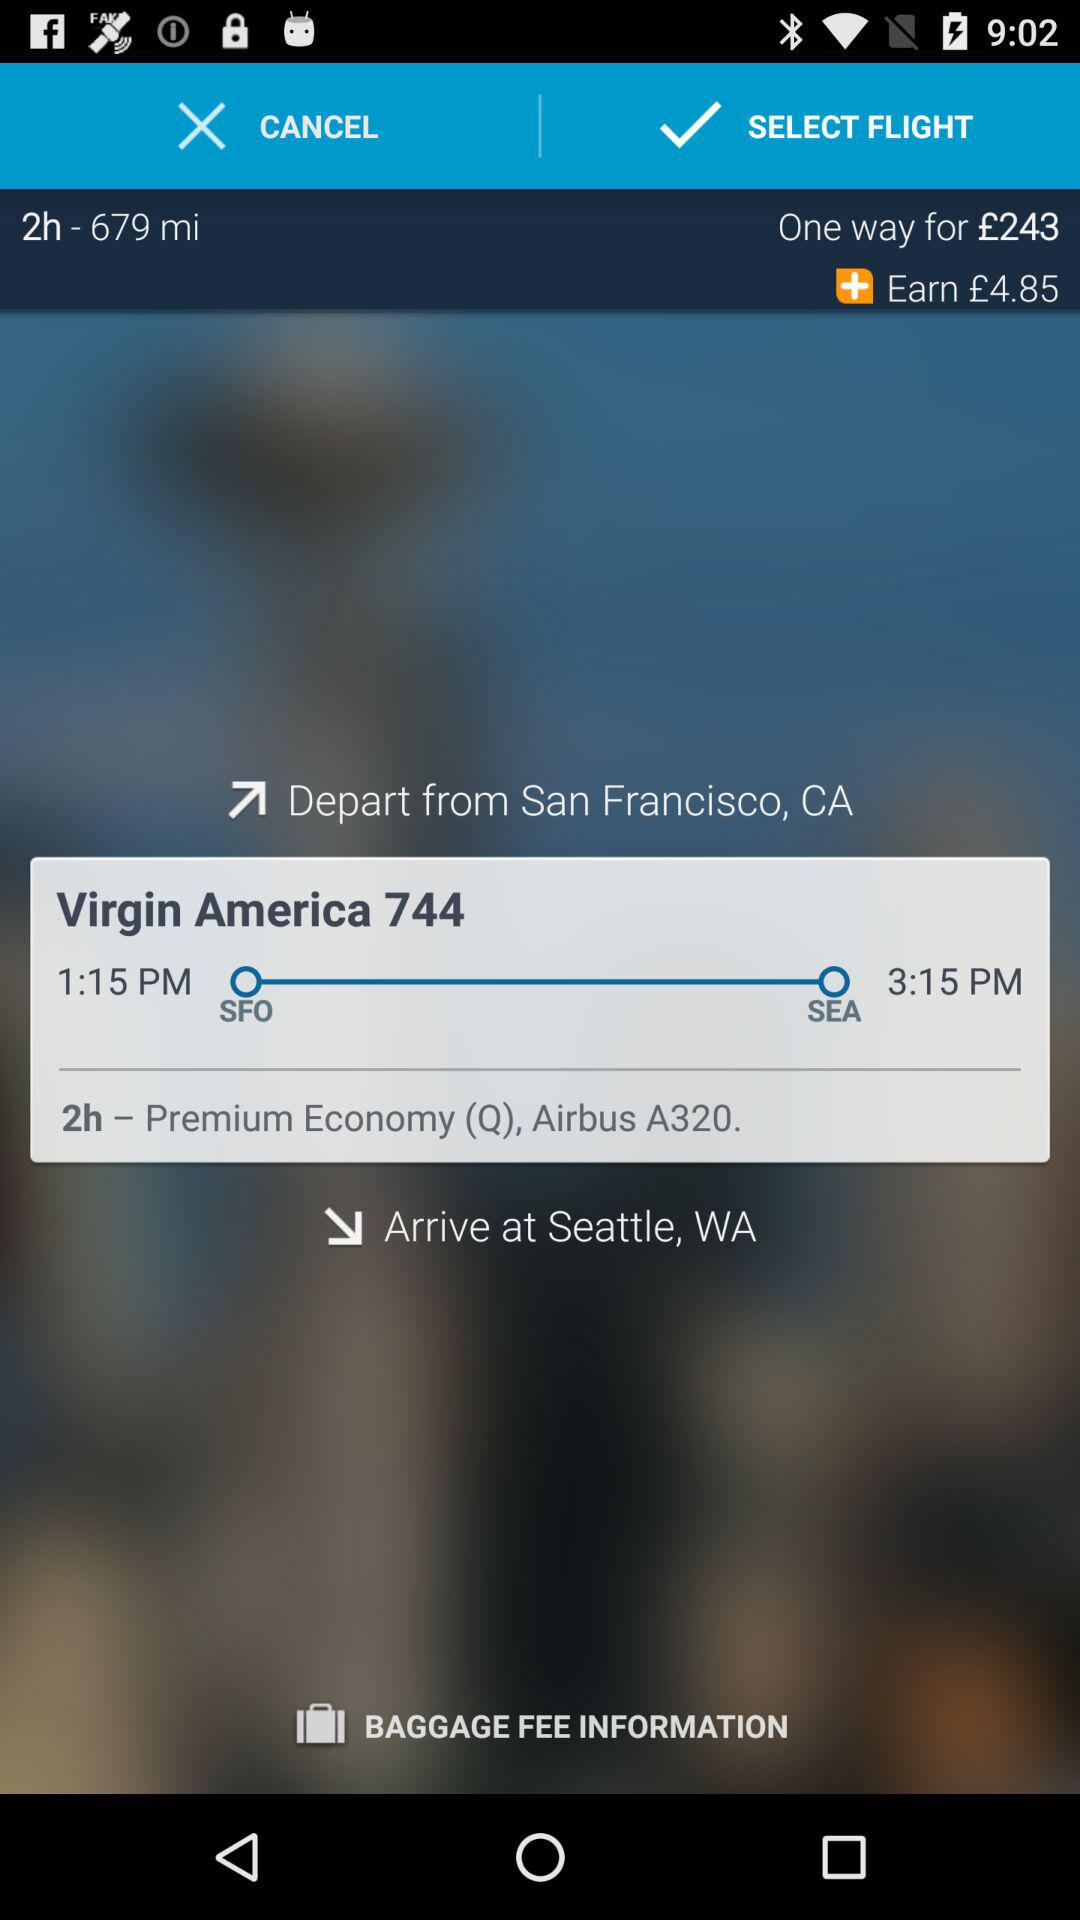What is the price of a one-way ticket? The price of a one-way ticket is £243. 